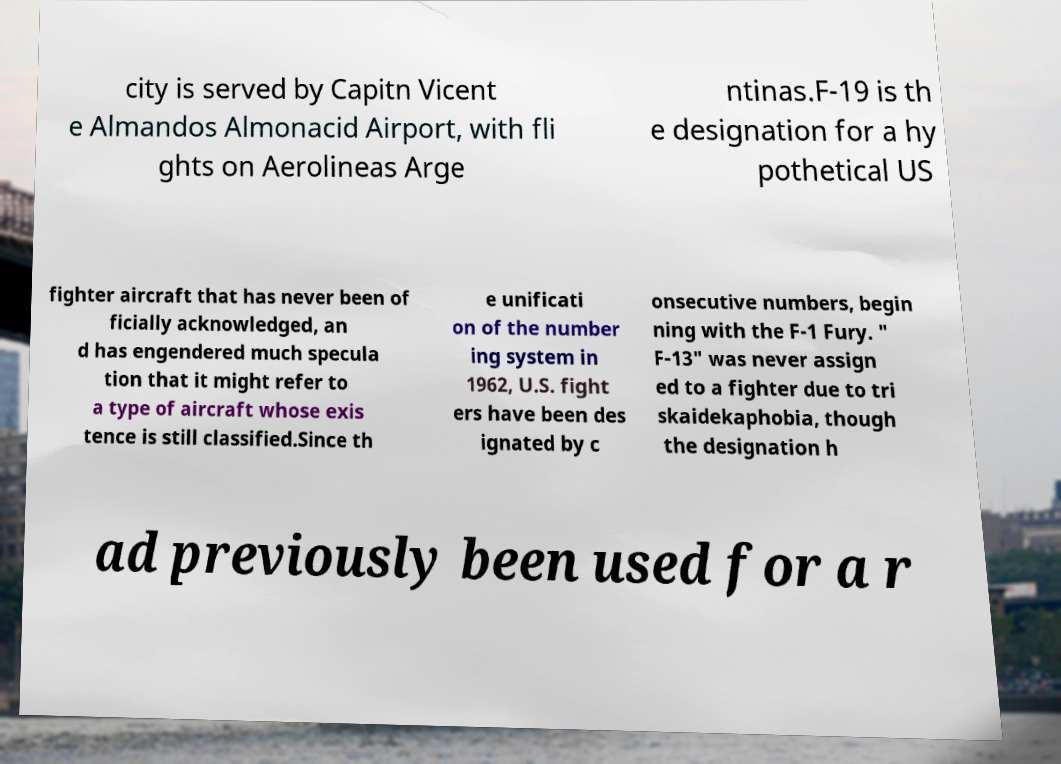Can you read and provide the text displayed in the image?This photo seems to have some interesting text. Can you extract and type it out for me? city is served by Capitn Vicent e Almandos Almonacid Airport, with fli ghts on Aerolineas Arge ntinas.F-19 is th e designation for a hy pothetical US fighter aircraft that has never been of ficially acknowledged, an d has engendered much specula tion that it might refer to a type of aircraft whose exis tence is still classified.Since th e unificati on of the number ing system in 1962, U.S. fight ers have been des ignated by c onsecutive numbers, begin ning with the F-1 Fury. " F-13" was never assign ed to a fighter due to tri skaidekaphobia, though the designation h ad previously been used for a r 